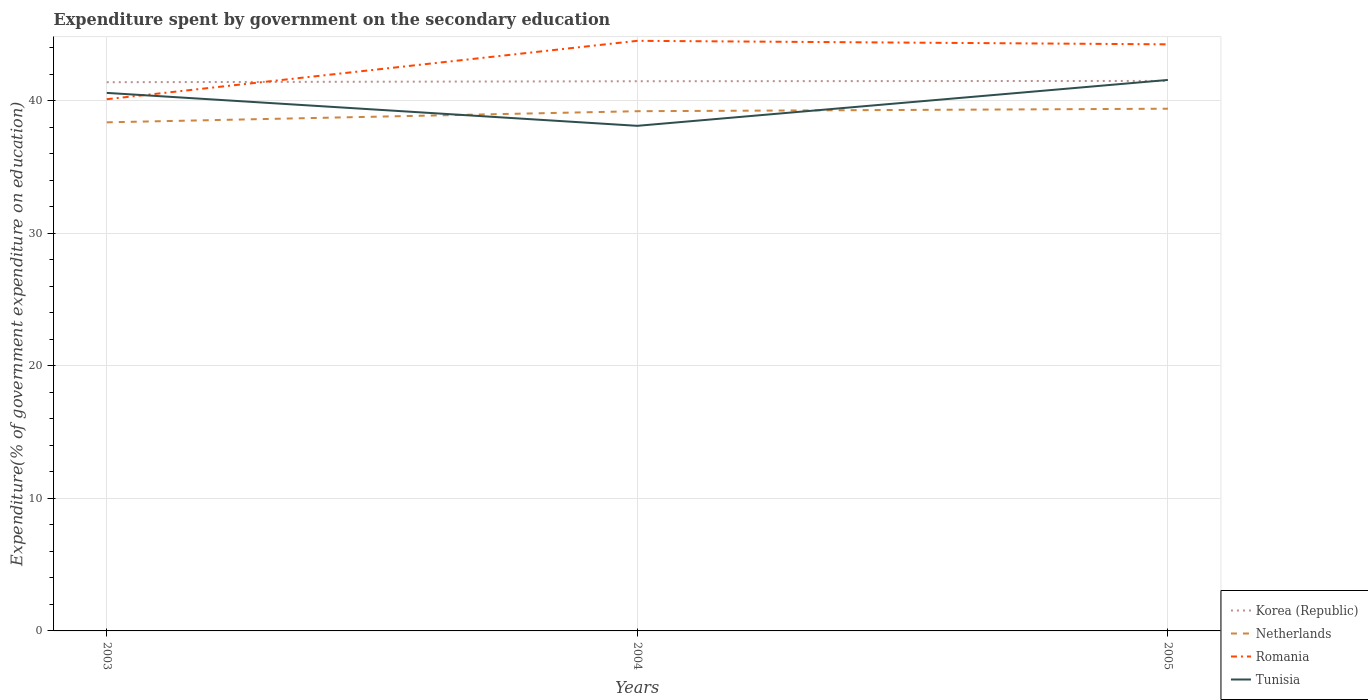Does the line corresponding to Tunisia intersect with the line corresponding to Netherlands?
Your answer should be compact. Yes. Is the number of lines equal to the number of legend labels?
Your answer should be compact. Yes. Across all years, what is the maximum expenditure spent by government on the secondary education in Romania?
Provide a succinct answer. 40.13. What is the total expenditure spent by government on the secondary education in Korea (Republic) in the graph?
Your answer should be compact. -0.02. What is the difference between the highest and the second highest expenditure spent by government on the secondary education in Romania?
Provide a succinct answer. 4.41. How many years are there in the graph?
Your answer should be compact. 3. What is the difference between two consecutive major ticks on the Y-axis?
Your answer should be compact. 10. Are the values on the major ticks of Y-axis written in scientific E-notation?
Offer a very short reply. No. Does the graph contain any zero values?
Ensure brevity in your answer.  No. Does the graph contain grids?
Your answer should be very brief. Yes. Where does the legend appear in the graph?
Your answer should be very brief. Bottom right. What is the title of the graph?
Provide a succinct answer. Expenditure spent by government on the secondary education. What is the label or title of the Y-axis?
Your answer should be very brief. Expenditure(% of government expenditure on education). What is the Expenditure(% of government expenditure on education) of Korea (Republic) in 2003?
Provide a succinct answer. 41.41. What is the Expenditure(% of government expenditure on education) in Netherlands in 2003?
Ensure brevity in your answer.  38.38. What is the Expenditure(% of government expenditure on education) in Romania in 2003?
Your answer should be very brief. 40.13. What is the Expenditure(% of government expenditure on education) in Tunisia in 2003?
Give a very brief answer. 40.61. What is the Expenditure(% of government expenditure on education) in Korea (Republic) in 2004?
Offer a terse response. 41.49. What is the Expenditure(% of government expenditure on education) of Netherlands in 2004?
Offer a terse response. 39.22. What is the Expenditure(% of government expenditure on education) of Romania in 2004?
Ensure brevity in your answer.  44.54. What is the Expenditure(% of government expenditure on education) of Tunisia in 2004?
Keep it short and to the point. 38.12. What is the Expenditure(% of government expenditure on education) in Korea (Republic) in 2005?
Keep it short and to the point. 41.51. What is the Expenditure(% of government expenditure on education) of Netherlands in 2005?
Provide a succinct answer. 39.41. What is the Expenditure(% of government expenditure on education) of Romania in 2005?
Give a very brief answer. 44.27. What is the Expenditure(% of government expenditure on education) of Tunisia in 2005?
Offer a very short reply. 41.58. Across all years, what is the maximum Expenditure(% of government expenditure on education) in Korea (Republic)?
Your response must be concise. 41.51. Across all years, what is the maximum Expenditure(% of government expenditure on education) in Netherlands?
Your response must be concise. 39.41. Across all years, what is the maximum Expenditure(% of government expenditure on education) of Romania?
Ensure brevity in your answer.  44.54. Across all years, what is the maximum Expenditure(% of government expenditure on education) in Tunisia?
Ensure brevity in your answer.  41.58. Across all years, what is the minimum Expenditure(% of government expenditure on education) in Korea (Republic)?
Make the answer very short. 41.41. Across all years, what is the minimum Expenditure(% of government expenditure on education) in Netherlands?
Your response must be concise. 38.38. Across all years, what is the minimum Expenditure(% of government expenditure on education) of Romania?
Give a very brief answer. 40.13. Across all years, what is the minimum Expenditure(% of government expenditure on education) of Tunisia?
Provide a short and direct response. 38.12. What is the total Expenditure(% of government expenditure on education) of Korea (Republic) in the graph?
Your response must be concise. 124.41. What is the total Expenditure(% of government expenditure on education) of Netherlands in the graph?
Provide a succinct answer. 117.02. What is the total Expenditure(% of government expenditure on education) of Romania in the graph?
Your answer should be compact. 128.94. What is the total Expenditure(% of government expenditure on education) of Tunisia in the graph?
Provide a succinct answer. 120.31. What is the difference between the Expenditure(% of government expenditure on education) of Korea (Republic) in 2003 and that in 2004?
Your response must be concise. -0.07. What is the difference between the Expenditure(% of government expenditure on education) in Netherlands in 2003 and that in 2004?
Your answer should be compact. -0.84. What is the difference between the Expenditure(% of government expenditure on education) of Romania in 2003 and that in 2004?
Make the answer very short. -4.41. What is the difference between the Expenditure(% of government expenditure on education) of Tunisia in 2003 and that in 2004?
Provide a succinct answer. 2.49. What is the difference between the Expenditure(% of government expenditure on education) of Korea (Republic) in 2003 and that in 2005?
Ensure brevity in your answer.  -0.1. What is the difference between the Expenditure(% of government expenditure on education) in Netherlands in 2003 and that in 2005?
Provide a succinct answer. -1.03. What is the difference between the Expenditure(% of government expenditure on education) of Romania in 2003 and that in 2005?
Your response must be concise. -4.14. What is the difference between the Expenditure(% of government expenditure on education) in Tunisia in 2003 and that in 2005?
Offer a very short reply. -0.98. What is the difference between the Expenditure(% of government expenditure on education) in Korea (Republic) in 2004 and that in 2005?
Ensure brevity in your answer.  -0.02. What is the difference between the Expenditure(% of government expenditure on education) in Netherlands in 2004 and that in 2005?
Your answer should be compact. -0.19. What is the difference between the Expenditure(% of government expenditure on education) in Romania in 2004 and that in 2005?
Your response must be concise. 0.26. What is the difference between the Expenditure(% of government expenditure on education) of Tunisia in 2004 and that in 2005?
Make the answer very short. -3.46. What is the difference between the Expenditure(% of government expenditure on education) of Korea (Republic) in 2003 and the Expenditure(% of government expenditure on education) of Netherlands in 2004?
Your response must be concise. 2.19. What is the difference between the Expenditure(% of government expenditure on education) of Korea (Republic) in 2003 and the Expenditure(% of government expenditure on education) of Romania in 2004?
Keep it short and to the point. -3.12. What is the difference between the Expenditure(% of government expenditure on education) in Korea (Republic) in 2003 and the Expenditure(% of government expenditure on education) in Tunisia in 2004?
Make the answer very short. 3.29. What is the difference between the Expenditure(% of government expenditure on education) of Netherlands in 2003 and the Expenditure(% of government expenditure on education) of Romania in 2004?
Keep it short and to the point. -6.15. What is the difference between the Expenditure(% of government expenditure on education) of Netherlands in 2003 and the Expenditure(% of government expenditure on education) of Tunisia in 2004?
Provide a succinct answer. 0.26. What is the difference between the Expenditure(% of government expenditure on education) in Romania in 2003 and the Expenditure(% of government expenditure on education) in Tunisia in 2004?
Give a very brief answer. 2.01. What is the difference between the Expenditure(% of government expenditure on education) in Korea (Republic) in 2003 and the Expenditure(% of government expenditure on education) in Netherlands in 2005?
Make the answer very short. 2. What is the difference between the Expenditure(% of government expenditure on education) in Korea (Republic) in 2003 and the Expenditure(% of government expenditure on education) in Romania in 2005?
Your response must be concise. -2.86. What is the difference between the Expenditure(% of government expenditure on education) of Korea (Republic) in 2003 and the Expenditure(% of government expenditure on education) of Tunisia in 2005?
Offer a very short reply. -0.17. What is the difference between the Expenditure(% of government expenditure on education) of Netherlands in 2003 and the Expenditure(% of government expenditure on education) of Romania in 2005?
Offer a terse response. -5.89. What is the difference between the Expenditure(% of government expenditure on education) of Netherlands in 2003 and the Expenditure(% of government expenditure on education) of Tunisia in 2005?
Your response must be concise. -3.2. What is the difference between the Expenditure(% of government expenditure on education) in Romania in 2003 and the Expenditure(% of government expenditure on education) in Tunisia in 2005?
Provide a short and direct response. -1.46. What is the difference between the Expenditure(% of government expenditure on education) in Korea (Republic) in 2004 and the Expenditure(% of government expenditure on education) in Netherlands in 2005?
Provide a short and direct response. 2.07. What is the difference between the Expenditure(% of government expenditure on education) of Korea (Republic) in 2004 and the Expenditure(% of government expenditure on education) of Romania in 2005?
Provide a succinct answer. -2.79. What is the difference between the Expenditure(% of government expenditure on education) in Korea (Republic) in 2004 and the Expenditure(% of government expenditure on education) in Tunisia in 2005?
Provide a short and direct response. -0.1. What is the difference between the Expenditure(% of government expenditure on education) of Netherlands in 2004 and the Expenditure(% of government expenditure on education) of Romania in 2005?
Make the answer very short. -5.05. What is the difference between the Expenditure(% of government expenditure on education) of Netherlands in 2004 and the Expenditure(% of government expenditure on education) of Tunisia in 2005?
Provide a short and direct response. -2.36. What is the difference between the Expenditure(% of government expenditure on education) in Romania in 2004 and the Expenditure(% of government expenditure on education) in Tunisia in 2005?
Make the answer very short. 2.95. What is the average Expenditure(% of government expenditure on education) of Korea (Republic) per year?
Make the answer very short. 41.47. What is the average Expenditure(% of government expenditure on education) in Netherlands per year?
Your answer should be compact. 39.01. What is the average Expenditure(% of government expenditure on education) of Romania per year?
Your answer should be very brief. 42.98. What is the average Expenditure(% of government expenditure on education) of Tunisia per year?
Provide a succinct answer. 40.1. In the year 2003, what is the difference between the Expenditure(% of government expenditure on education) in Korea (Republic) and Expenditure(% of government expenditure on education) in Netherlands?
Offer a very short reply. 3.03. In the year 2003, what is the difference between the Expenditure(% of government expenditure on education) in Korea (Republic) and Expenditure(% of government expenditure on education) in Romania?
Give a very brief answer. 1.28. In the year 2003, what is the difference between the Expenditure(% of government expenditure on education) in Korea (Republic) and Expenditure(% of government expenditure on education) in Tunisia?
Your answer should be compact. 0.81. In the year 2003, what is the difference between the Expenditure(% of government expenditure on education) in Netherlands and Expenditure(% of government expenditure on education) in Romania?
Offer a terse response. -1.74. In the year 2003, what is the difference between the Expenditure(% of government expenditure on education) of Netherlands and Expenditure(% of government expenditure on education) of Tunisia?
Ensure brevity in your answer.  -2.22. In the year 2003, what is the difference between the Expenditure(% of government expenditure on education) of Romania and Expenditure(% of government expenditure on education) of Tunisia?
Provide a succinct answer. -0.48. In the year 2004, what is the difference between the Expenditure(% of government expenditure on education) of Korea (Republic) and Expenditure(% of government expenditure on education) of Netherlands?
Give a very brief answer. 2.26. In the year 2004, what is the difference between the Expenditure(% of government expenditure on education) of Korea (Republic) and Expenditure(% of government expenditure on education) of Romania?
Your answer should be compact. -3.05. In the year 2004, what is the difference between the Expenditure(% of government expenditure on education) of Korea (Republic) and Expenditure(% of government expenditure on education) of Tunisia?
Your response must be concise. 3.36. In the year 2004, what is the difference between the Expenditure(% of government expenditure on education) of Netherlands and Expenditure(% of government expenditure on education) of Romania?
Ensure brevity in your answer.  -5.31. In the year 2004, what is the difference between the Expenditure(% of government expenditure on education) of Netherlands and Expenditure(% of government expenditure on education) of Tunisia?
Your answer should be compact. 1.1. In the year 2004, what is the difference between the Expenditure(% of government expenditure on education) in Romania and Expenditure(% of government expenditure on education) in Tunisia?
Your answer should be compact. 6.42. In the year 2005, what is the difference between the Expenditure(% of government expenditure on education) of Korea (Republic) and Expenditure(% of government expenditure on education) of Netherlands?
Your response must be concise. 2.1. In the year 2005, what is the difference between the Expenditure(% of government expenditure on education) in Korea (Republic) and Expenditure(% of government expenditure on education) in Romania?
Make the answer very short. -2.76. In the year 2005, what is the difference between the Expenditure(% of government expenditure on education) of Korea (Republic) and Expenditure(% of government expenditure on education) of Tunisia?
Your answer should be very brief. -0.07. In the year 2005, what is the difference between the Expenditure(% of government expenditure on education) of Netherlands and Expenditure(% of government expenditure on education) of Romania?
Your answer should be very brief. -4.86. In the year 2005, what is the difference between the Expenditure(% of government expenditure on education) of Netherlands and Expenditure(% of government expenditure on education) of Tunisia?
Offer a very short reply. -2.17. In the year 2005, what is the difference between the Expenditure(% of government expenditure on education) in Romania and Expenditure(% of government expenditure on education) in Tunisia?
Make the answer very short. 2.69. What is the ratio of the Expenditure(% of government expenditure on education) of Netherlands in 2003 to that in 2004?
Your answer should be compact. 0.98. What is the ratio of the Expenditure(% of government expenditure on education) in Romania in 2003 to that in 2004?
Your answer should be very brief. 0.9. What is the ratio of the Expenditure(% of government expenditure on education) in Tunisia in 2003 to that in 2004?
Give a very brief answer. 1.07. What is the ratio of the Expenditure(% of government expenditure on education) of Korea (Republic) in 2003 to that in 2005?
Your response must be concise. 1. What is the ratio of the Expenditure(% of government expenditure on education) in Netherlands in 2003 to that in 2005?
Ensure brevity in your answer.  0.97. What is the ratio of the Expenditure(% of government expenditure on education) in Romania in 2003 to that in 2005?
Give a very brief answer. 0.91. What is the ratio of the Expenditure(% of government expenditure on education) of Tunisia in 2003 to that in 2005?
Offer a very short reply. 0.98. What is the difference between the highest and the second highest Expenditure(% of government expenditure on education) in Korea (Republic)?
Keep it short and to the point. 0.02. What is the difference between the highest and the second highest Expenditure(% of government expenditure on education) in Netherlands?
Your response must be concise. 0.19. What is the difference between the highest and the second highest Expenditure(% of government expenditure on education) in Romania?
Give a very brief answer. 0.26. What is the difference between the highest and the second highest Expenditure(% of government expenditure on education) of Tunisia?
Offer a very short reply. 0.98. What is the difference between the highest and the lowest Expenditure(% of government expenditure on education) of Korea (Republic)?
Ensure brevity in your answer.  0.1. What is the difference between the highest and the lowest Expenditure(% of government expenditure on education) of Netherlands?
Offer a very short reply. 1.03. What is the difference between the highest and the lowest Expenditure(% of government expenditure on education) in Romania?
Make the answer very short. 4.41. What is the difference between the highest and the lowest Expenditure(% of government expenditure on education) of Tunisia?
Keep it short and to the point. 3.46. 